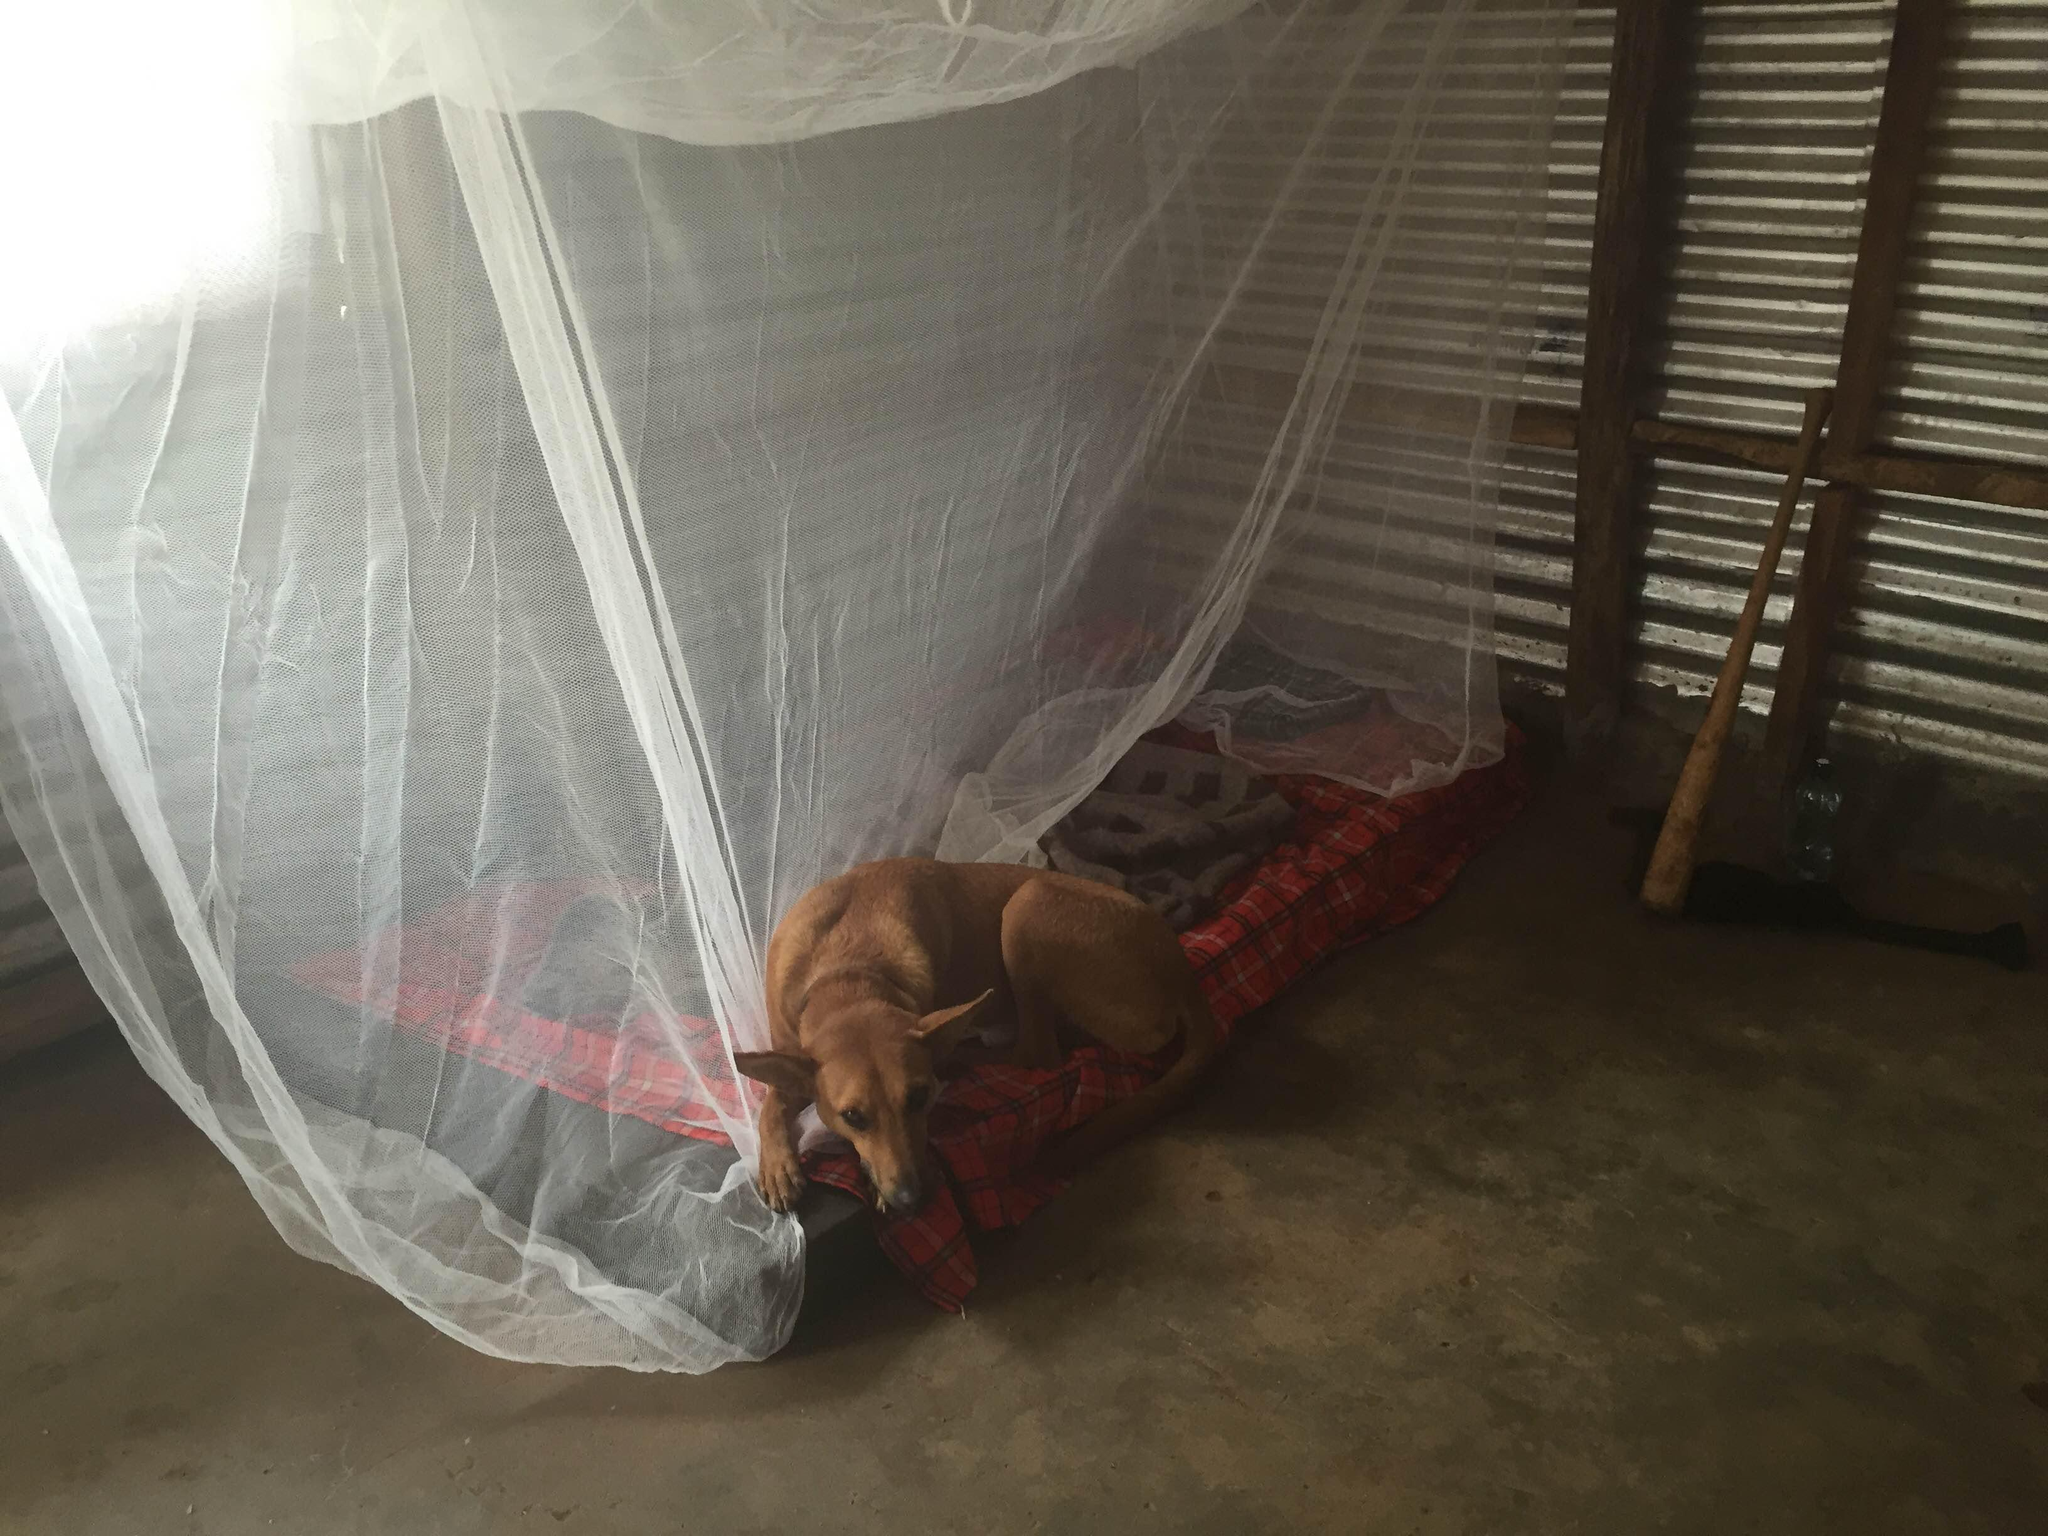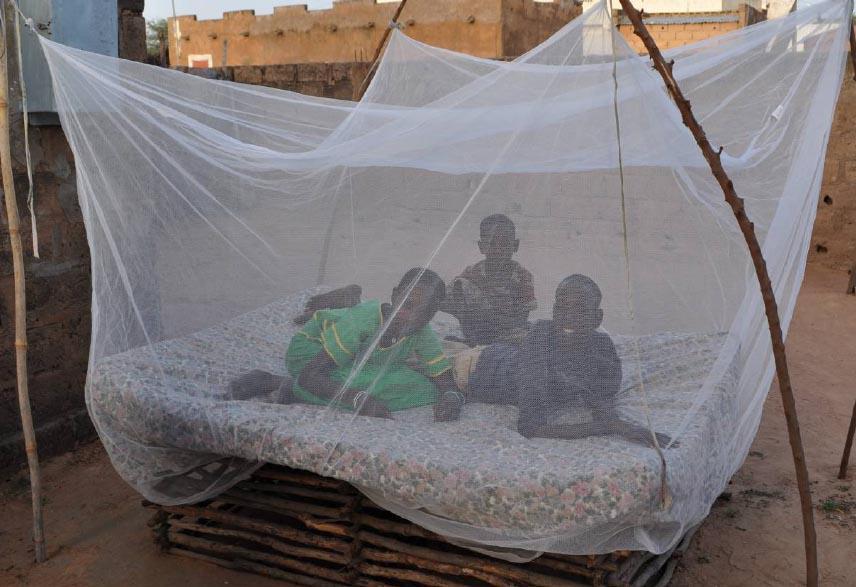The first image is the image on the left, the second image is the image on the right. Examine the images to the left and right. Is the description "An image includes a young baby sleeping under a protective net." accurate? Answer yes or no. No. 